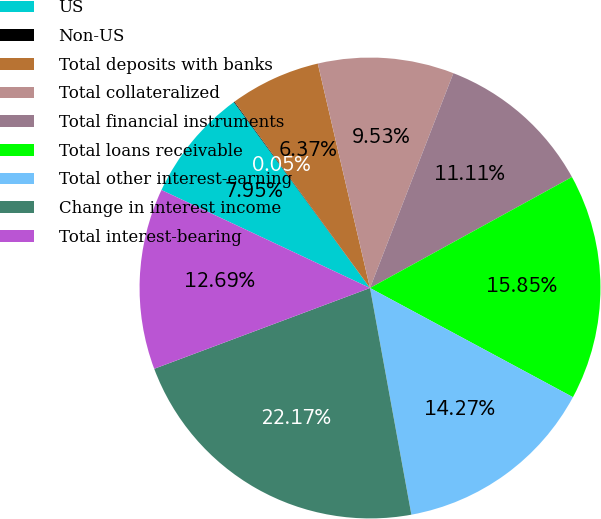<chart> <loc_0><loc_0><loc_500><loc_500><pie_chart><fcel>US<fcel>Non-US<fcel>Total deposits with banks<fcel>Total collateralized<fcel>Total financial instruments<fcel>Total loans receivable<fcel>Total other interest-earning<fcel>Change in interest income<fcel>Total interest-bearing<nl><fcel>7.95%<fcel>0.05%<fcel>6.37%<fcel>9.53%<fcel>11.11%<fcel>15.85%<fcel>14.27%<fcel>22.17%<fcel>12.69%<nl></chart> 